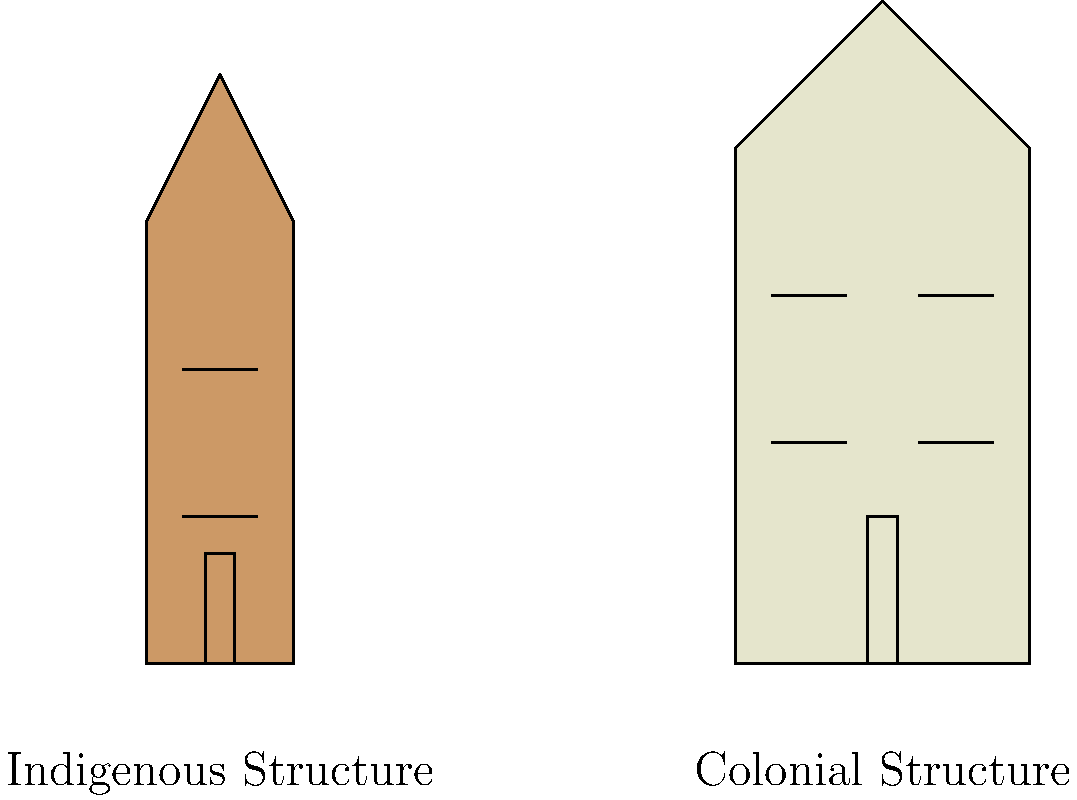Based on the elevation drawings of indigenous and colonial structures, what key architectural difference can be observed in the roof design, and how might this reflect the cultural and environmental adaptations of each group? To answer this question, we need to analyze the roof designs of both structures:

1. Indigenous structure:
   - The roof has a steep, pointed design
   - It forms a triangular shape at the top

2. Colonial structure:
   - The roof has a less steep, more gradual slope
   - It forms a wider, flatter top

3. Cultural and environmental adaptations:
   - Indigenous roof:
     a. Steeper design allows for better shedding of heavy rainfall or snow
     b. Pointed top might reflect spiritual beliefs or connection to the sky
     c. Simpler construction using local materials

   - Colonial roof:
     a. Less steep design suitable for milder climates
     b. Wider, flatter top allows for more interior space on upper floors
     c. Reflects European architectural styles and building techniques

4. Key difference:
   The indigenous roof is steeper and more pointed, while the colonial roof is less steep with a flatter top.

5. Reflection of adaptations:
   The indigenous design shows adaptation to local climate and traditional beliefs, while the colonial design showcases imported architectural styles and the desire for more interior space.
Answer: The key difference is the roof steepness: indigenous roofs are steeper and pointed, adapting to local climate and beliefs, while colonial roofs are less steep with flatter tops, reflecting European styles and prioritizing interior space. 